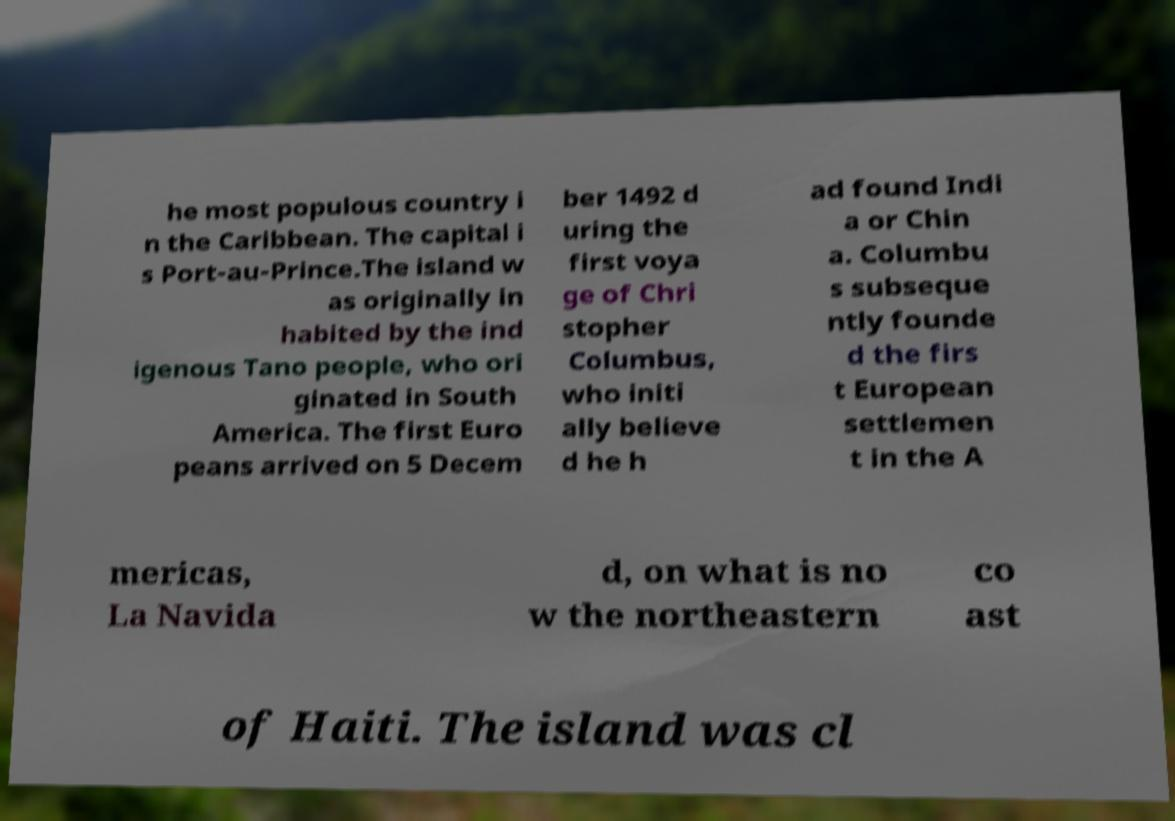Please identify and transcribe the text found in this image. he most populous country i n the Caribbean. The capital i s Port-au-Prince.The island w as originally in habited by the ind igenous Tano people, who ori ginated in South America. The first Euro peans arrived on 5 Decem ber 1492 d uring the first voya ge of Chri stopher Columbus, who initi ally believe d he h ad found Indi a or Chin a. Columbu s subseque ntly founde d the firs t European settlemen t in the A mericas, La Navida d, on what is no w the northeastern co ast of Haiti. The island was cl 